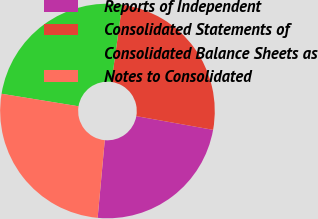<chart> <loc_0><loc_0><loc_500><loc_500><pie_chart><fcel>Reports of Independent<fcel>Consolidated Statements of<fcel>Consolidated Balance Sheets as<fcel>Notes to Consolidated<nl><fcel>23.65%<fcel>25.62%<fcel>24.63%<fcel>26.11%<nl></chart> 